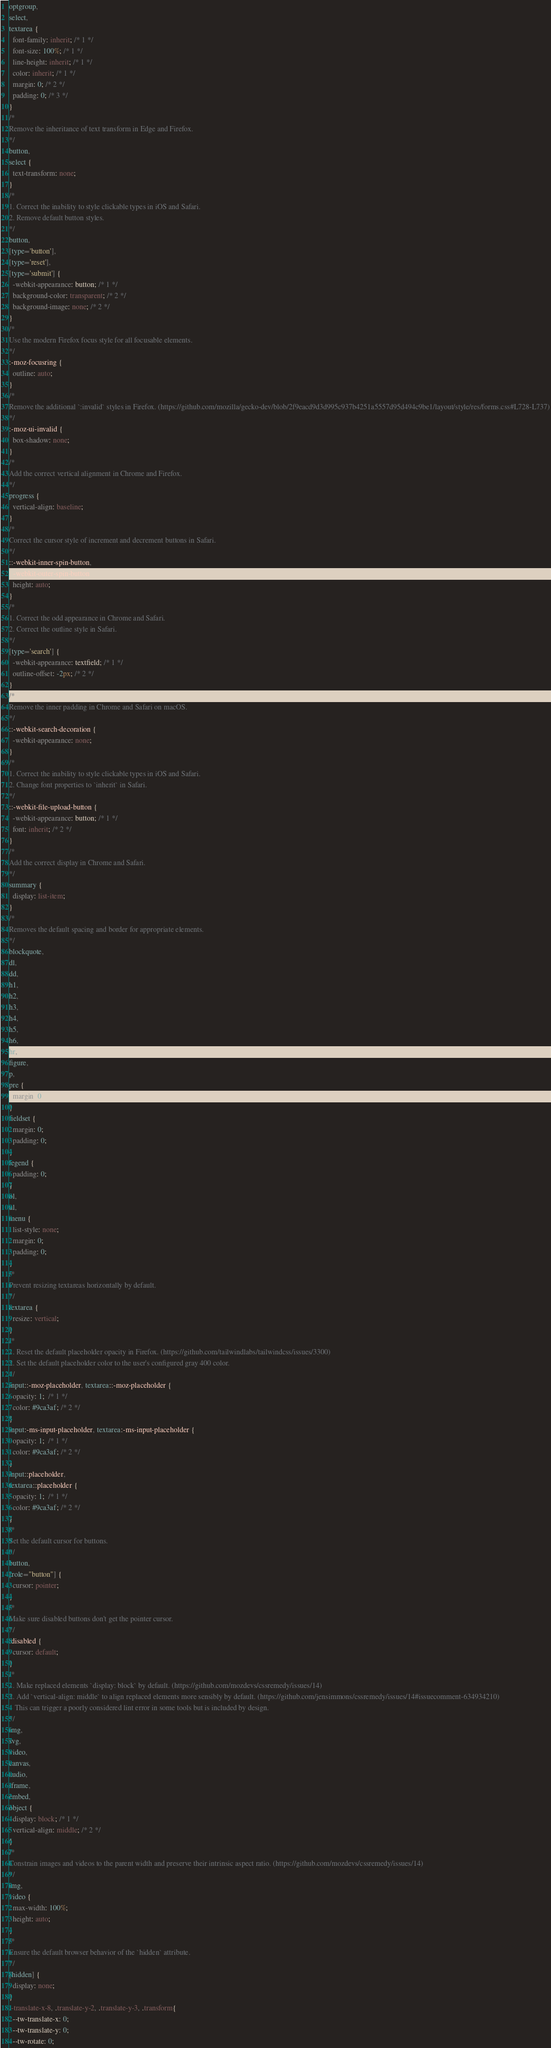<code> <loc_0><loc_0><loc_500><loc_500><_CSS_>optgroup,
select,
textarea {
  font-family: inherit; /* 1 */
  font-size: 100%; /* 1 */
  line-height: inherit; /* 1 */
  color: inherit; /* 1 */
  margin: 0; /* 2 */
  padding: 0; /* 3 */
}
/*
Remove the inheritance of text transform in Edge and Firefox.
*/
button,
select {
  text-transform: none;
}
/*
1. Correct the inability to style clickable types in iOS and Safari.
2. Remove default button styles.
*/
button,
[type='button'],
[type='reset'],
[type='submit'] {
  -webkit-appearance: button; /* 1 */
  background-color: transparent; /* 2 */
  background-image: none; /* 2 */
}
/*
Use the modern Firefox focus style for all focusable elements.
*/
:-moz-focusring {
  outline: auto;
}
/*
Remove the additional `:invalid` styles in Firefox. (https://github.com/mozilla/gecko-dev/blob/2f9eacd9d3d995c937b4251a5557d95d494c9be1/layout/style/res/forms.css#L728-L737)
*/
:-moz-ui-invalid {
  box-shadow: none;
}
/*
Add the correct vertical alignment in Chrome and Firefox.
*/
progress {
  vertical-align: baseline;
}
/*
Correct the cursor style of increment and decrement buttons in Safari.
*/
::-webkit-inner-spin-button,
::-webkit-outer-spin-button {
  height: auto;
}
/*
1. Correct the odd appearance in Chrome and Safari.
2. Correct the outline style in Safari.
*/
[type='search'] {
  -webkit-appearance: textfield; /* 1 */
  outline-offset: -2px; /* 2 */
}
/*
Remove the inner padding in Chrome and Safari on macOS.
*/
::-webkit-search-decoration {
  -webkit-appearance: none;
}
/*
1. Correct the inability to style clickable types in iOS and Safari.
2. Change font properties to `inherit` in Safari.
*/
::-webkit-file-upload-button {
  -webkit-appearance: button; /* 1 */
  font: inherit; /* 2 */
}
/*
Add the correct display in Chrome and Safari.
*/
summary {
  display: list-item;
}
/*
Removes the default spacing and border for appropriate elements.
*/
blockquote,
dl,
dd,
h1,
h2,
h3,
h4,
h5,
h6,
hr,
figure,
p,
pre {
  margin: 0;
}
fieldset {
  margin: 0;
  padding: 0;
}
legend {
  padding: 0;
}
ol,
ul,
menu {
  list-style: none;
  margin: 0;
  padding: 0;
}
/*
Prevent resizing textareas horizontally by default.
*/
textarea {
  resize: vertical;
}
/*
1. Reset the default placeholder opacity in Firefox. (https://github.com/tailwindlabs/tailwindcss/issues/3300)
2. Set the default placeholder color to the user's configured gray 400 color.
*/
input::-moz-placeholder, textarea::-moz-placeholder {
  opacity: 1;  /* 1 */
  color: #9ca3af; /* 2 */
}
input:-ms-input-placeholder, textarea:-ms-input-placeholder {
  opacity: 1;  /* 1 */
  color: #9ca3af; /* 2 */
}
input::placeholder,
textarea::placeholder {
  opacity: 1;  /* 1 */
  color: #9ca3af; /* 2 */
}
/*
Set the default cursor for buttons.
*/
button,
[role="button"] {
  cursor: pointer;
}
/*
Make sure disabled buttons don't get the pointer cursor.
*/
:disabled {
  cursor: default;
}
/*
1. Make replaced elements `display: block` by default. (https://github.com/mozdevs/cssremedy/issues/14)
2. Add `vertical-align: middle` to align replaced elements more sensibly by default. (https://github.com/jensimmons/cssremedy/issues/14#issuecomment-634934210)
   This can trigger a poorly considered lint error in some tools but is included by design.
*/
img,
svg,
video,
canvas,
audio,
iframe,
embed,
object {
  display: block; /* 1 */
  vertical-align: middle; /* 2 */
}
/*
Constrain images and videos to the parent width and preserve their intrinsic aspect ratio. (https://github.com/mozdevs/cssremedy/issues/14)
*/
img,
video {
  max-width: 100%;
  height: auto;
}
/*
Ensure the default browser behavior of the `hidden` attribute.
*/
[hidden] {
  display: none;
}
.-translate-x-8, .translate-y-2, .translate-y-3, .transform{
  --tw-translate-x: 0;
  --tw-translate-y: 0;
  --tw-rotate: 0;</code> 